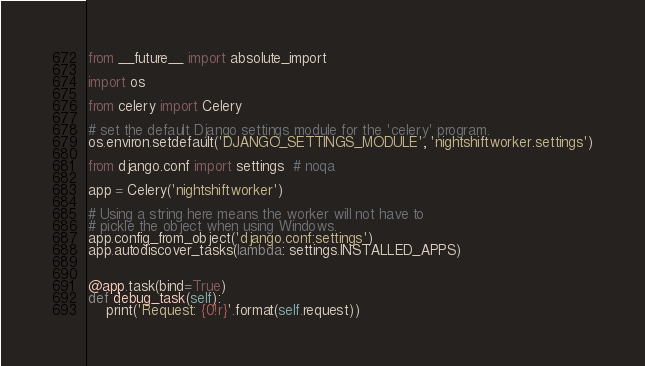Convert code to text. <code><loc_0><loc_0><loc_500><loc_500><_Python_>from __future__ import absolute_import

import os

from celery import Celery

# set the default Django settings module for the 'celery' program.
os.environ.setdefault('DJANGO_SETTINGS_MODULE', 'nightshiftworker.settings')

from django.conf import settings  # noqa

app = Celery('nightshiftworker')

# Using a string here means the worker will not have to
# pickle the object when using Windows.
app.config_from_object('django.conf:settings')
app.autodiscover_tasks(lambda: settings.INSTALLED_APPS)


@app.task(bind=True)
def debug_task(self):
    print('Request: {0!r}'.format(self.request))
</code> 